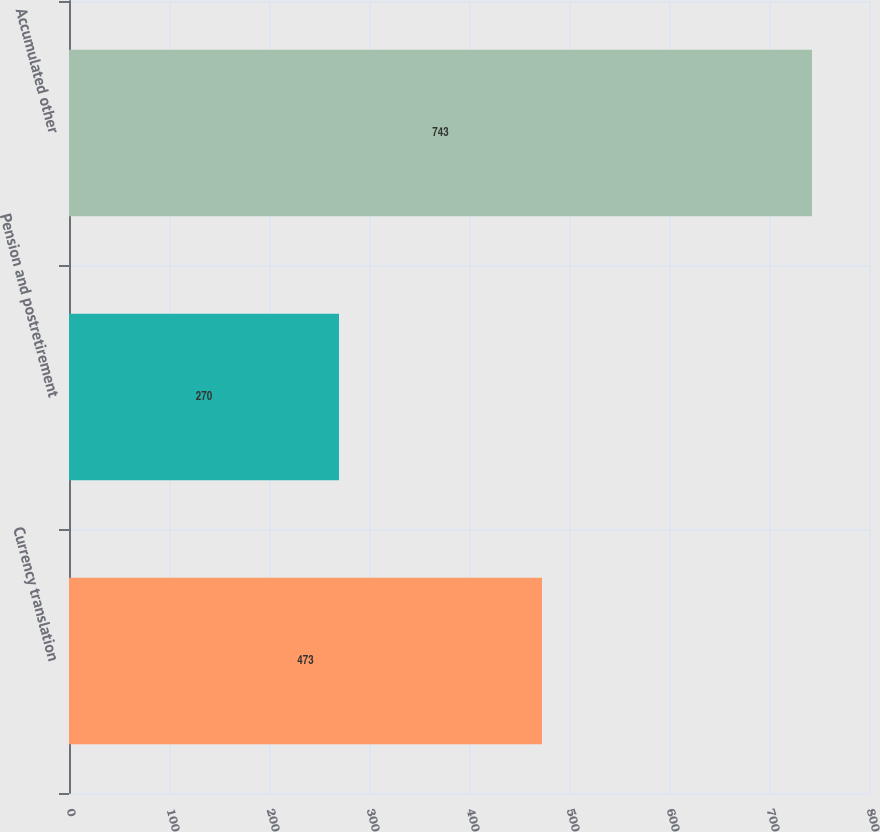<chart> <loc_0><loc_0><loc_500><loc_500><bar_chart><fcel>Currency translation<fcel>Pension and postretirement<fcel>Accumulated other<nl><fcel>473<fcel>270<fcel>743<nl></chart> 